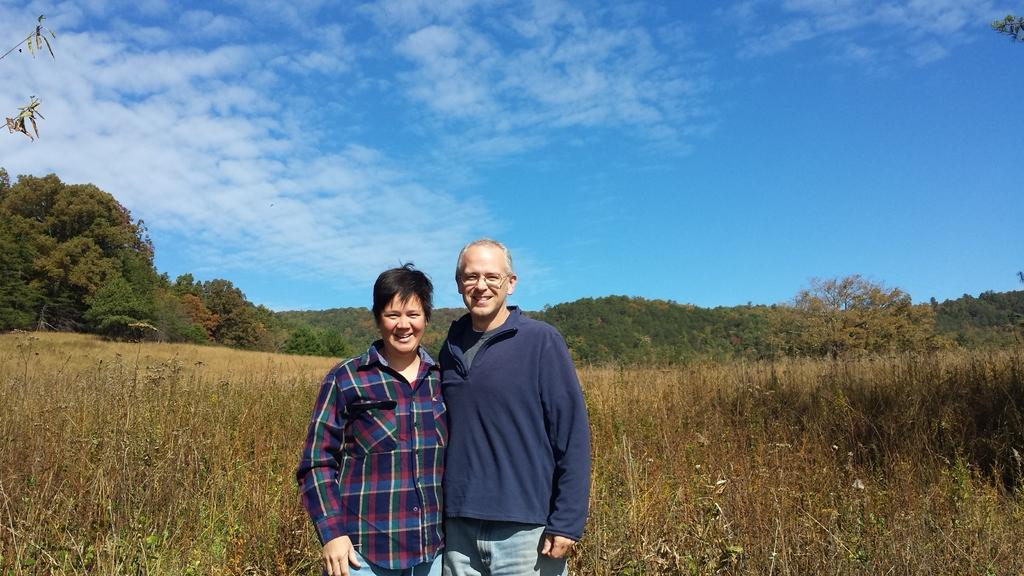How many people are in the image? There are two persons standing in the image. What is the facial expression of the persons? The persons are smiling. What type of vegetation can be seen in the image? There are plants and trees visible in the image. What is visible in the background of the image? The sky is visible in the background of the image. What can be observed in the sky? Clouds are present in the sky. What type of argument can be heard between the two persons in the image? There is no indication of an argument in the image; the persons are smiling. How many cars are parked near the trees in the image? There are no cars present in the image; it only features two persons, plants, trees, and the sky. 